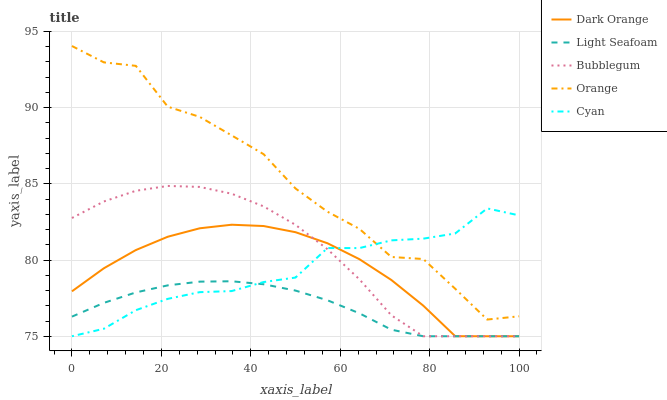Does Light Seafoam have the minimum area under the curve?
Answer yes or no. Yes. Does Orange have the maximum area under the curve?
Answer yes or no. Yes. Does Dark Orange have the minimum area under the curve?
Answer yes or no. No. Does Dark Orange have the maximum area under the curve?
Answer yes or no. No. Is Light Seafoam the smoothest?
Answer yes or no. Yes. Is Orange the roughest?
Answer yes or no. Yes. Is Dark Orange the smoothest?
Answer yes or no. No. Is Dark Orange the roughest?
Answer yes or no. No. Does Dark Orange have the lowest value?
Answer yes or no. Yes. Does Orange have the highest value?
Answer yes or no. Yes. Does Dark Orange have the highest value?
Answer yes or no. No. Is Bubblegum less than Orange?
Answer yes or no. Yes. Is Orange greater than Light Seafoam?
Answer yes or no. Yes. Does Orange intersect Cyan?
Answer yes or no. Yes. Is Orange less than Cyan?
Answer yes or no. No. Is Orange greater than Cyan?
Answer yes or no. No. Does Bubblegum intersect Orange?
Answer yes or no. No. 